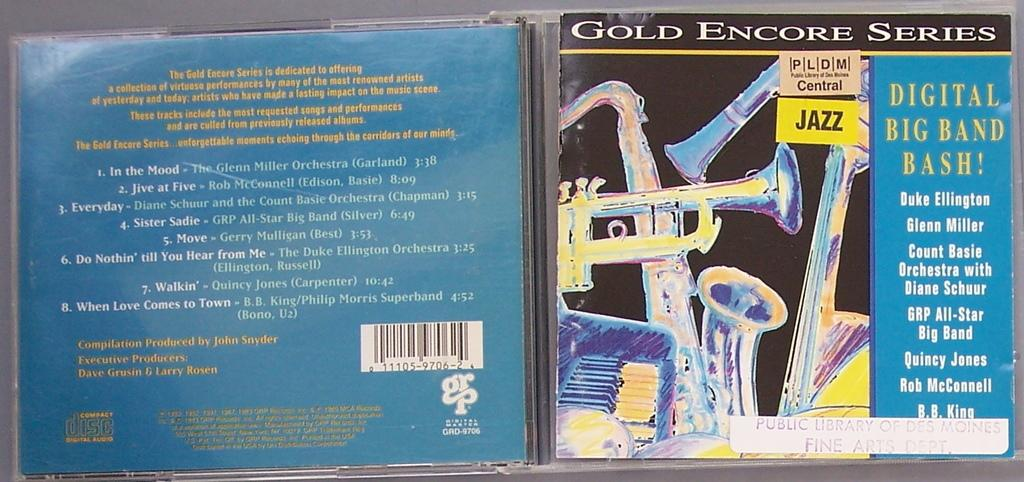<image>
Render a clear and concise summary of the photo. A CD from the Gold Encore Series features big band jazz. 